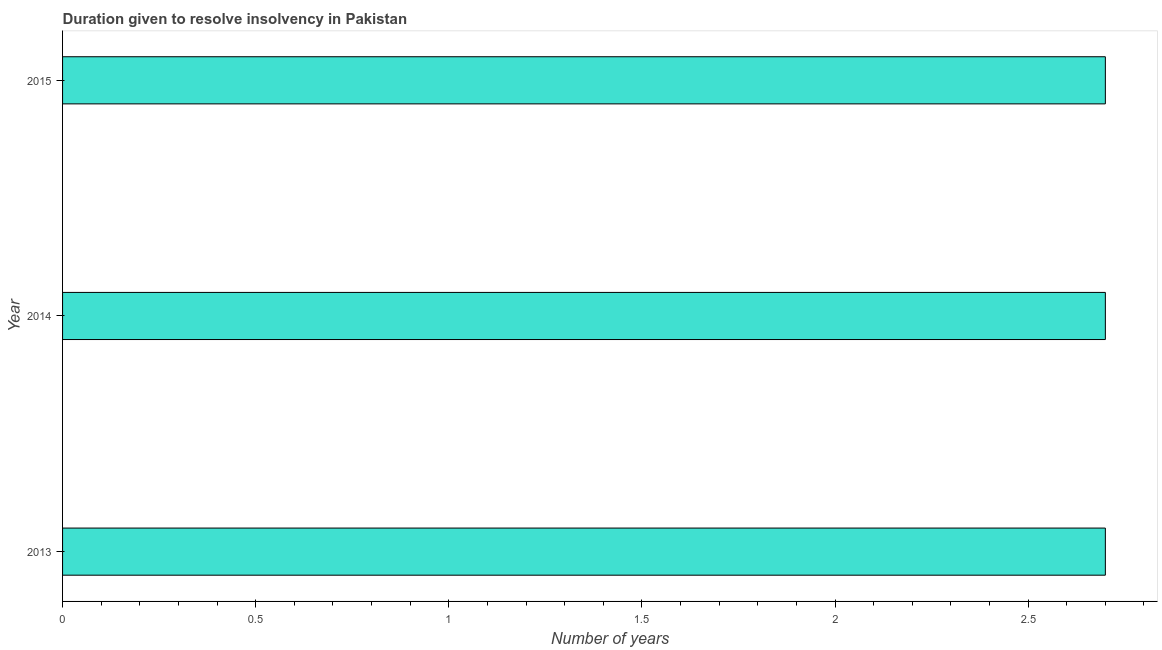What is the title of the graph?
Your answer should be very brief. Duration given to resolve insolvency in Pakistan. What is the label or title of the X-axis?
Provide a succinct answer. Number of years. What is the label or title of the Y-axis?
Make the answer very short. Year. What is the number of years to resolve insolvency in 2014?
Offer a terse response. 2.7. Across all years, what is the maximum number of years to resolve insolvency?
Your response must be concise. 2.7. In which year was the number of years to resolve insolvency maximum?
Your answer should be very brief. 2013. What is the sum of the number of years to resolve insolvency?
Ensure brevity in your answer.  8.1. What is the median number of years to resolve insolvency?
Ensure brevity in your answer.  2.7. What is the ratio of the number of years to resolve insolvency in 2013 to that in 2014?
Your answer should be very brief. 1. Is the number of years to resolve insolvency in 2014 less than that in 2015?
Provide a succinct answer. No. Is the difference between the number of years to resolve insolvency in 2013 and 2015 greater than the difference between any two years?
Your answer should be compact. Yes. What is the difference between the highest and the second highest number of years to resolve insolvency?
Provide a succinct answer. 0. Is the sum of the number of years to resolve insolvency in 2013 and 2014 greater than the maximum number of years to resolve insolvency across all years?
Keep it short and to the point. Yes. In how many years, is the number of years to resolve insolvency greater than the average number of years to resolve insolvency taken over all years?
Offer a very short reply. 0. Are all the bars in the graph horizontal?
Keep it short and to the point. Yes. What is the difference between two consecutive major ticks on the X-axis?
Your answer should be very brief. 0.5. What is the difference between the Number of years in 2013 and 2014?
Keep it short and to the point. 0. What is the difference between the Number of years in 2013 and 2015?
Your response must be concise. 0. What is the ratio of the Number of years in 2013 to that in 2014?
Offer a very short reply. 1. What is the ratio of the Number of years in 2014 to that in 2015?
Your answer should be very brief. 1. 